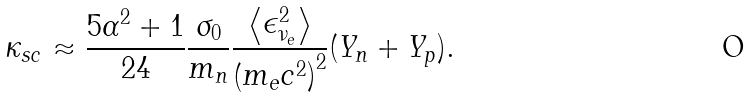<formula> <loc_0><loc_0><loc_500><loc_500>\kappa _ { s c } \approx { \frac { 5 \alpha ^ { 2 } + 1 } { 2 4 } } \frac { \sigma _ { 0 } } { m _ { n } } \frac { \left < \epsilon ^ { 2 } _ { \nu _ { e } } \right > } { \left ( m _ { e } c ^ { 2 } \right ) ^ { 2 } } ( Y _ { n } + Y _ { p } ) .</formula> 